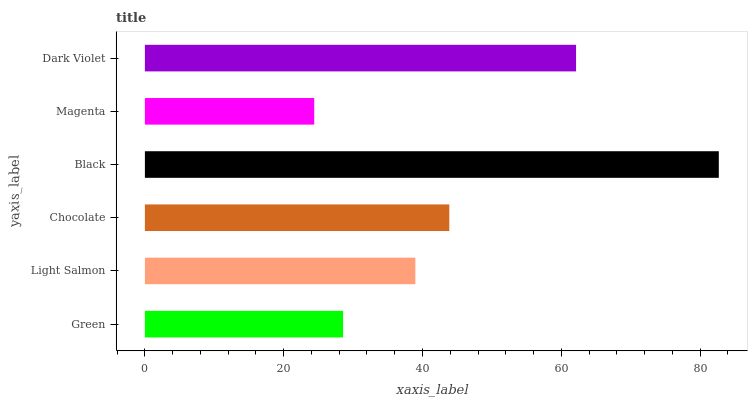Is Magenta the minimum?
Answer yes or no. Yes. Is Black the maximum?
Answer yes or no. Yes. Is Light Salmon the minimum?
Answer yes or no. No. Is Light Salmon the maximum?
Answer yes or no. No. Is Light Salmon greater than Green?
Answer yes or no. Yes. Is Green less than Light Salmon?
Answer yes or no. Yes. Is Green greater than Light Salmon?
Answer yes or no. No. Is Light Salmon less than Green?
Answer yes or no. No. Is Chocolate the high median?
Answer yes or no. Yes. Is Light Salmon the low median?
Answer yes or no. Yes. Is Black the high median?
Answer yes or no. No. Is Dark Violet the low median?
Answer yes or no. No. 